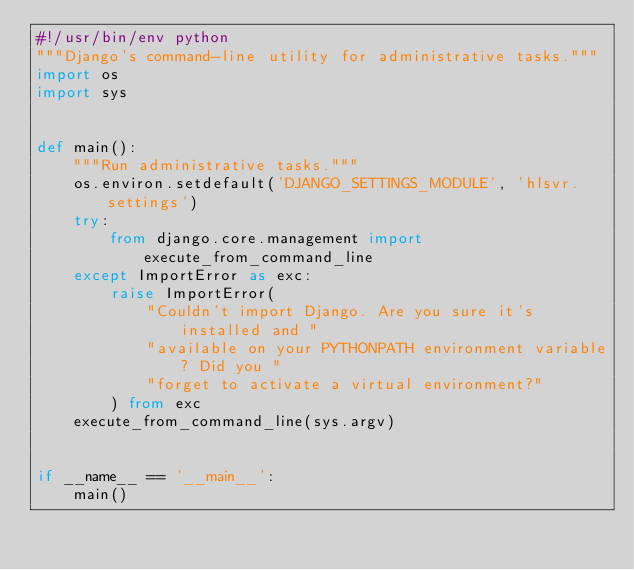Convert code to text. <code><loc_0><loc_0><loc_500><loc_500><_Python_>#!/usr/bin/env python
"""Django's command-line utility for administrative tasks."""
import os
import sys


def main():
    """Run administrative tasks."""
    os.environ.setdefault('DJANGO_SETTINGS_MODULE', 'hlsvr.settings')
    try:
        from django.core.management import execute_from_command_line
    except ImportError as exc:
        raise ImportError(
            "Couldn't import Django. Are you sure it's installed and "
            "available on your PYTHONPATH environment variable? Did you "
            "forget to activate a virtual environment?"
        ) from exc
    execute_from_command_line(sys.argv)


if __name__ == '__main__':
    main()
</code> 